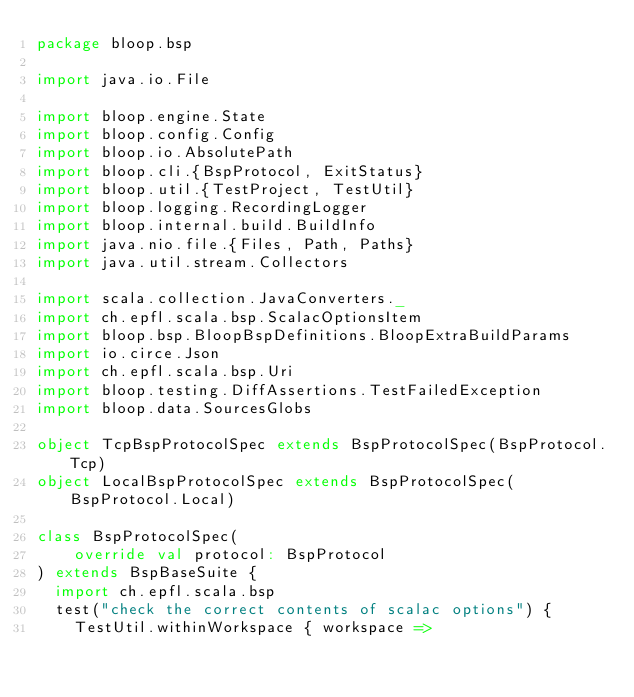Convert code to text. <code><loc_0><loc_0><loc_500><loc_500><_Scala_>package bloop.bsp

import java.io.File

import bloop.engine.State
import bloop.config.Config
import bloop.io.AbsolutePath
import bloop.cli.{BspProtocol, ExitStatus}
import bloop.util.{TestProject, TestUtil}
import bloop.logging.RecordingLogger
import bloop.internal.build.BuildInfo
import java.nio.file.{Files, Path, Paths}
import java.util.stream.Collectors

import scala.collection.JavaConverters._
import ch.epfl.scala.bsp.ScalacOptionsItem
import bloop.bsp.BloopBspDefinitions.BloopExtraBuildParams
import io.circe.Json
import ch.epfl.scala.bsp.Uri
import bloop.testing.DiffAssertions.TestFailedException
import bloop.data.SourcesGlobs

object TcpBspProtocolSpec extends BspProtocolSpec(BspProtocol.Tcp)
object LocalBspProtocolSpec extends BspProtocolSpec(BspProtocol.Local)

class BspProtocolSpec(
    override val protocol: BspProtocol
) extends BspBaseSuite {
  import ch.epfl.scala.bsp
  test("check the correct contents of scalac options") {
    TestUtil.withinWorkspace { workspace =></code> 